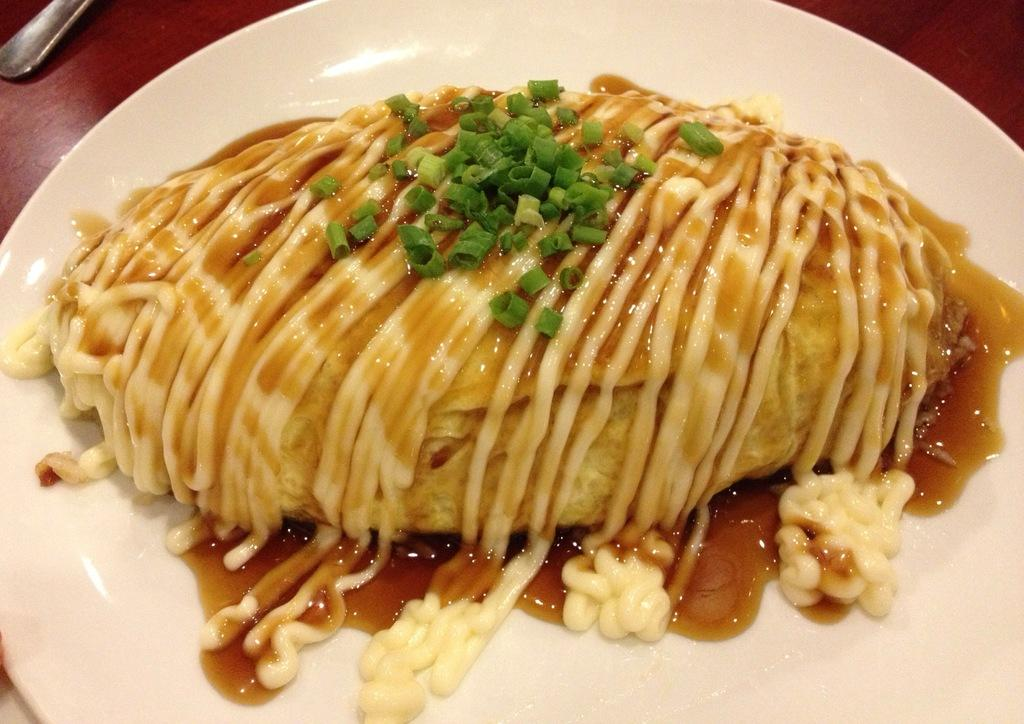What type of surface is visible in the image? There is a wooden surface in the image. What is placed on the wooden surface? There is a plate on the wooden surface. What color is the plate? The plate is white in color. What can be seen on the plate? There is a food item on the plate. What type of celery can be seen in the image? There is no celery present in the image. How many cars are visible in the image? There are no cars visible in the image. 